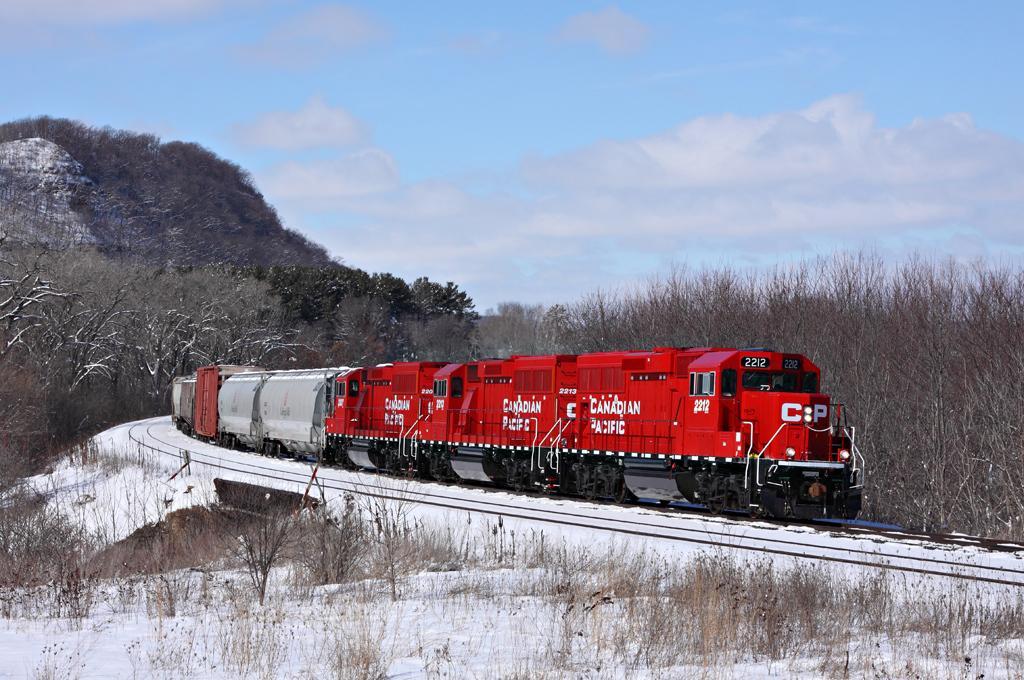How would you summarize this image in a sentence or two? Here in this picture we can see a train present on the railway track over there and we can see snow present over there and we can see plants and trees present on either side of it over there and behind it we can see a hill present, which is covered with plants over there and we can also see clouds in the sky. 